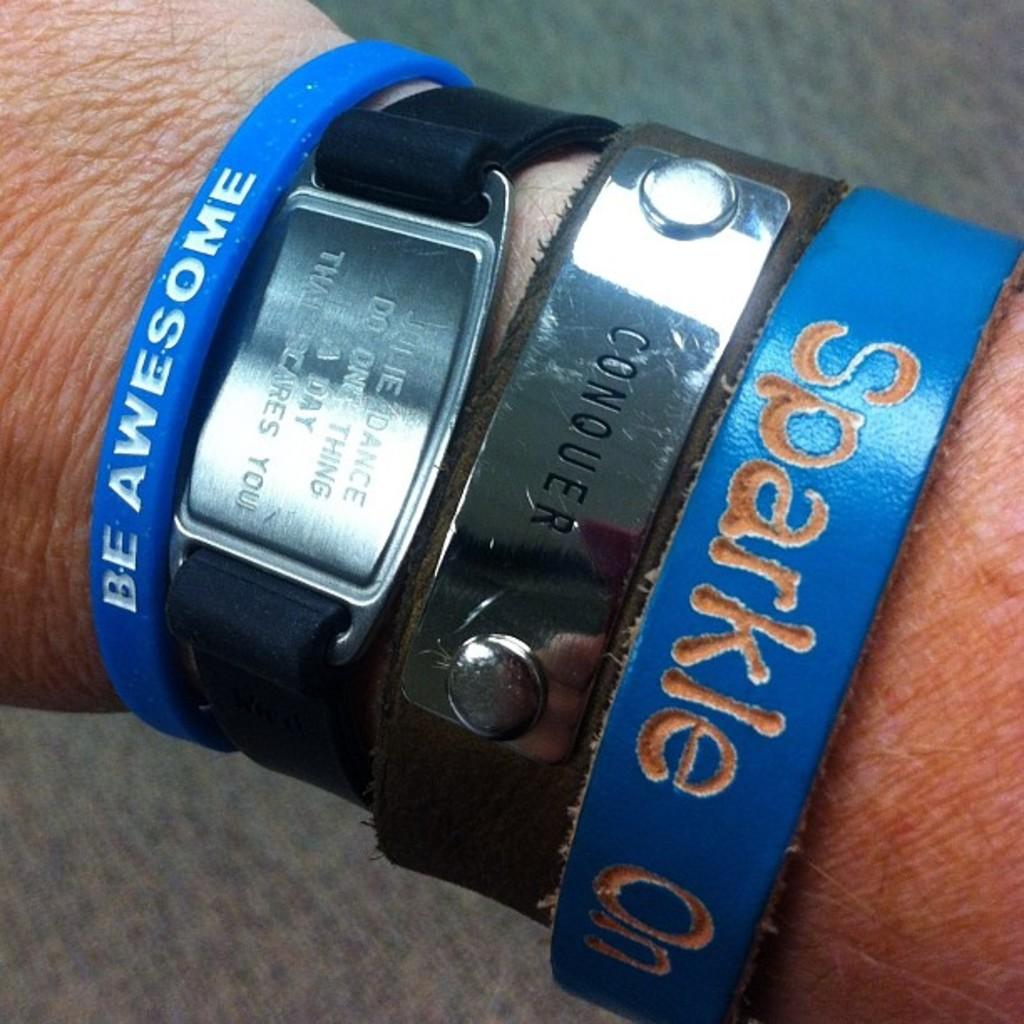<image>
Present a compact description of the photo's key features. A man is wearing bracelets that say be awesome and sparkle on. 